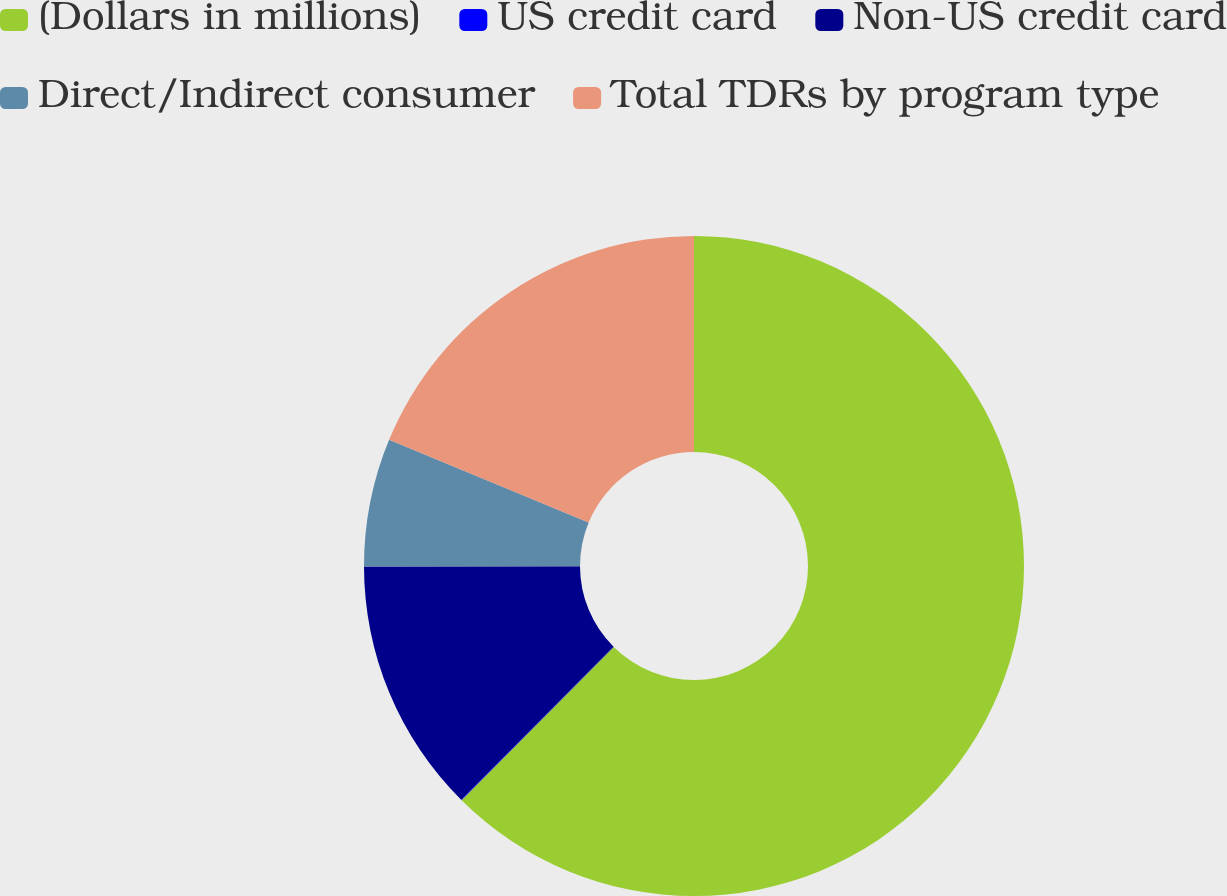Convert chart. <chart><loc_0><loc_0><loc_500><loc_500><pie_chart><fcel>(Dollars in millions)<fcel>US credit card<fcel>Non-US credit card<fcel>Direct/Indirect consumer<fcel>Total TDRs by program type<nl><fcel>62.43%<fcel>0.03%<fcel>12.51%<fcel>6.27%<fcel>18.75%<nl></chart> 